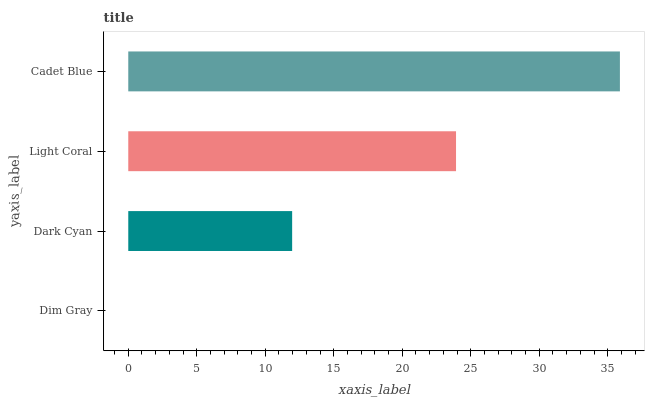Is Dim Gray the minimum?
Answer yes or no. Yes. Is Cadet Blue the maximum?
Answer yes or no. Yes. Is Dark Cyan the minimum?
Answer yes or no. No. Is Dark Cyan the maximum?
Answer yes or no. No. Is Dark Cyan greater than Dim Gray?
Answer yes or no. Yes. Is Dim Gray less than Dark Cyan?
Answer yes or no. Yes. Is Dim Gray greater than Dark Cyan?
Answer yes or no. No. Is Dark Cyan less than Dim Gray?
Answer yes or no. No. Is Light Coral the high median?
Answer yes or no. Yes. Is Dark Cyan the low median?
Answer yes or no. Yes. Is Cadet Blue the high median?
Answer yes or no. No. Is Cadet Blue the low median?
Answer yes or no. No. 